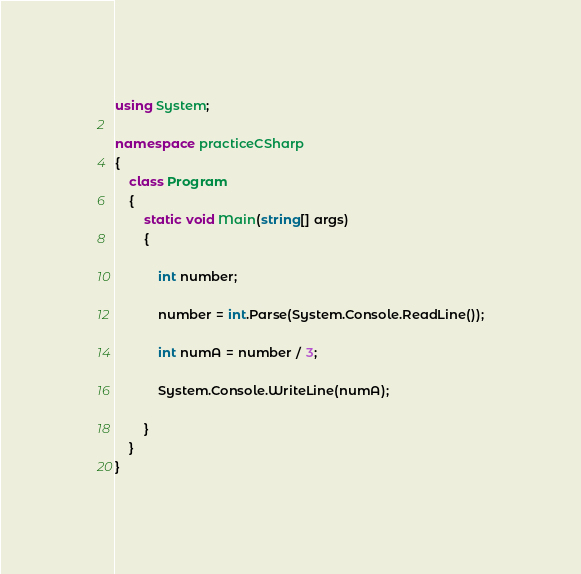Convert code to text. <code><loc_0><loc_0><loc_500><loc_500><_C#_>using System;

namespace practiceCSharp
{
    class Program
    {
        static void Main(string[] args)
        {

            int number;

            number = int.Parse(System.Console.ReadLine());

            int numA = number / 3;

            System.Console.WriteLine(numA);

        }
    }
}
</code> 